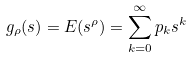Convert formula to latex. <formula><loc_0><loc_0><loc_500><loc_500>g _ { \rho } ( s ) = E ( s ^ { \rho } ) = \sum _ { k = 0 } ^ { \infty } p _ { k } s ^ { k }</formula> 